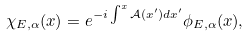Convert formula to latex. <formula><loc_0><loc_0><loc_500><loc_500>\chi _ { E , \alpha } ( x ) = e ^ { - i \int ^ { x } \mathcal { A } ( x ^ { \prime } ) d x ^ { \prime } } \phi _ { E , \alpha } ( x ) ,</formula> 